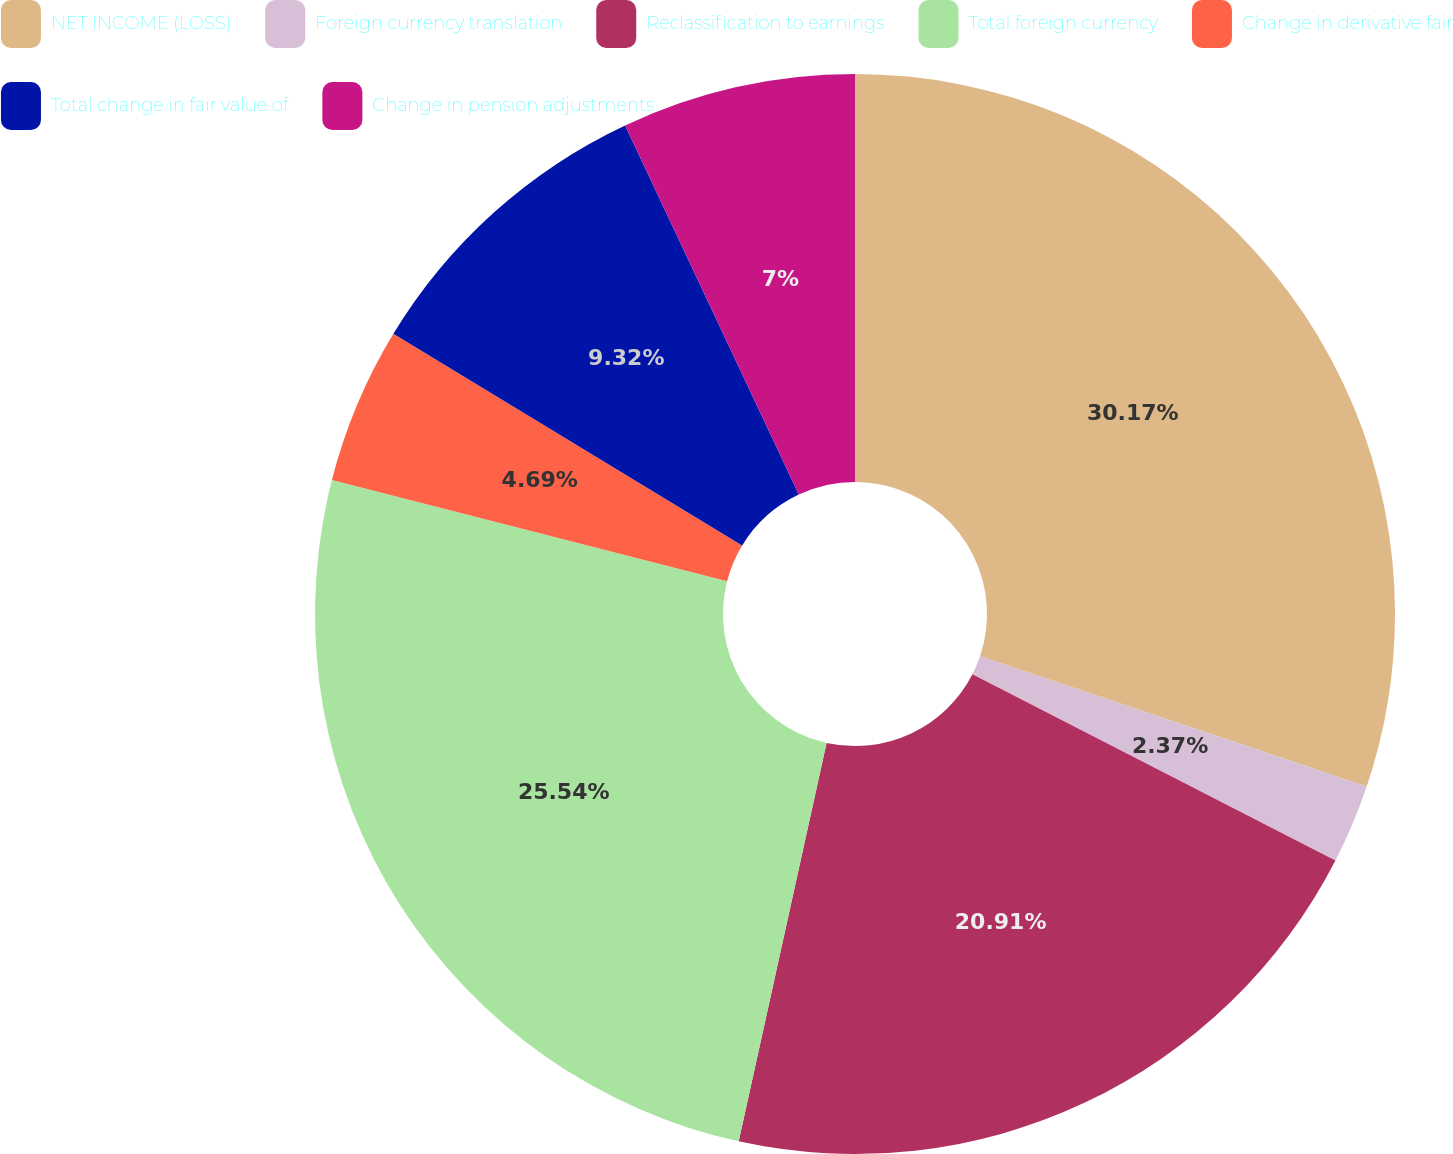Convert chart to OTSL. <chart><loc_0><loc_0><loc_500><loc_500><pie_chart><fcel>NET INCOME (LOSS)<fcel>Foreign currency translation<fcel>Reclassification to earnings<fcel>Total foreign currency<fcel>Change in derivative fair<fcel>Total change in fair value of<fcel>Change in pension adjustments<nl><fcel>30.18%<fcel>2.37%<fcel>20.91%<fcel>25.54%<fcel>4.69%<fcel>9.32%<fcel>7.0%<nl></chart> 